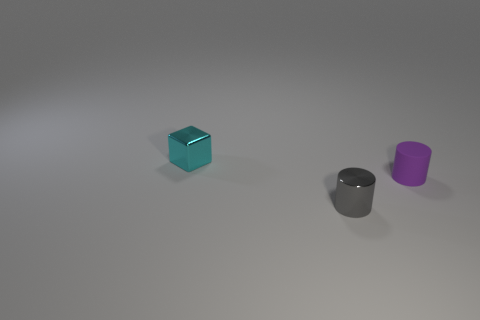How many large shiny objects are there?
Your response must be concise. 0. How many tiny objects are on the left side of the tiny purple cylinder and right of the cyan metallic object?
Provide a short and direct response. 1. What material is the tiny purple object?
Your answer should be very brief. Rubber. Is there a big red cube?
Ensure brevity in your answer.  No. What is the color of the metallic object in front of the cube?
Your response must be concise. Gray. What number of tiny shiny objects are in front of the tiny matte object behind the shiny object that is in front of the cyan cube?
Offer a very short reply. 1. The thing that is both behind the tiny gray metallic object and in front of the tiny block is made of what material?
Provide a succinct answer. Rubber. Are the tiny cyan cube and the cylinder that is on the left side of the small purple rubber cylinder made of the same material?
Your answer should be very brief. Yes. Is the number of cylinders that are to the left of the tiny purple matte cylinder greater than the number of cylinders left of the gray metal thing?
Your answer should be very brief. Yes. What is the shape of the tiny purple object?
Provide a short and direct response. Cylinder. 